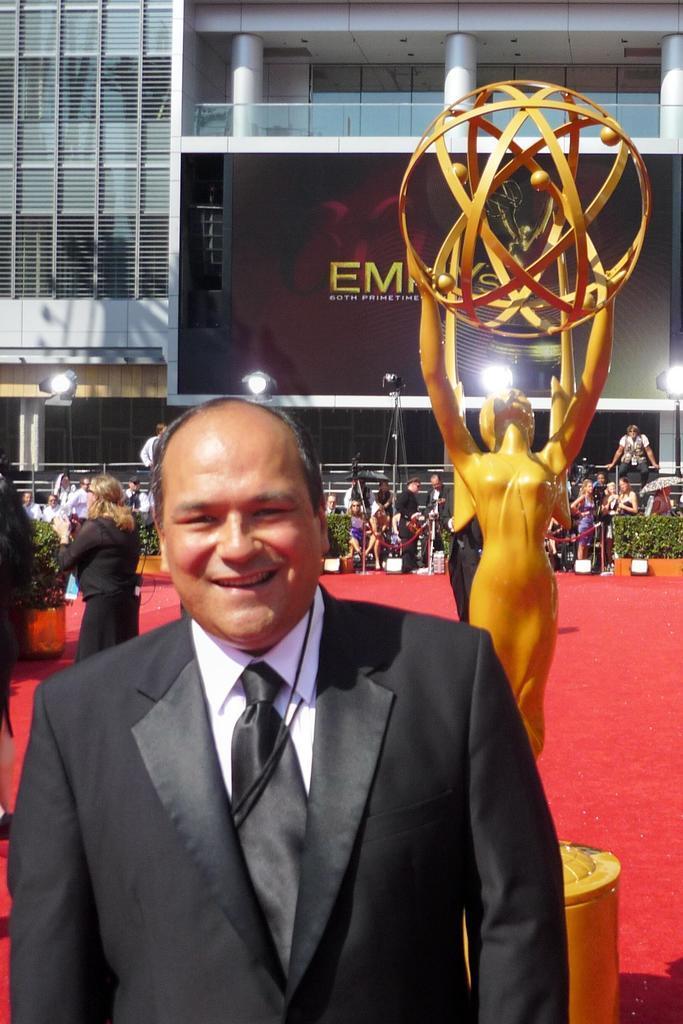How would you summarize this image in a sentence or two? In the center of the image, we can see a sculpture and in the background, there are people and are wearing coats and we can see lights, plants, a board and there is a building. At the bottom, there is a carpet. 